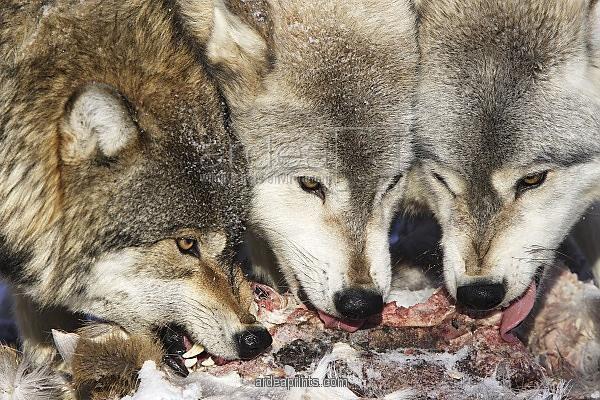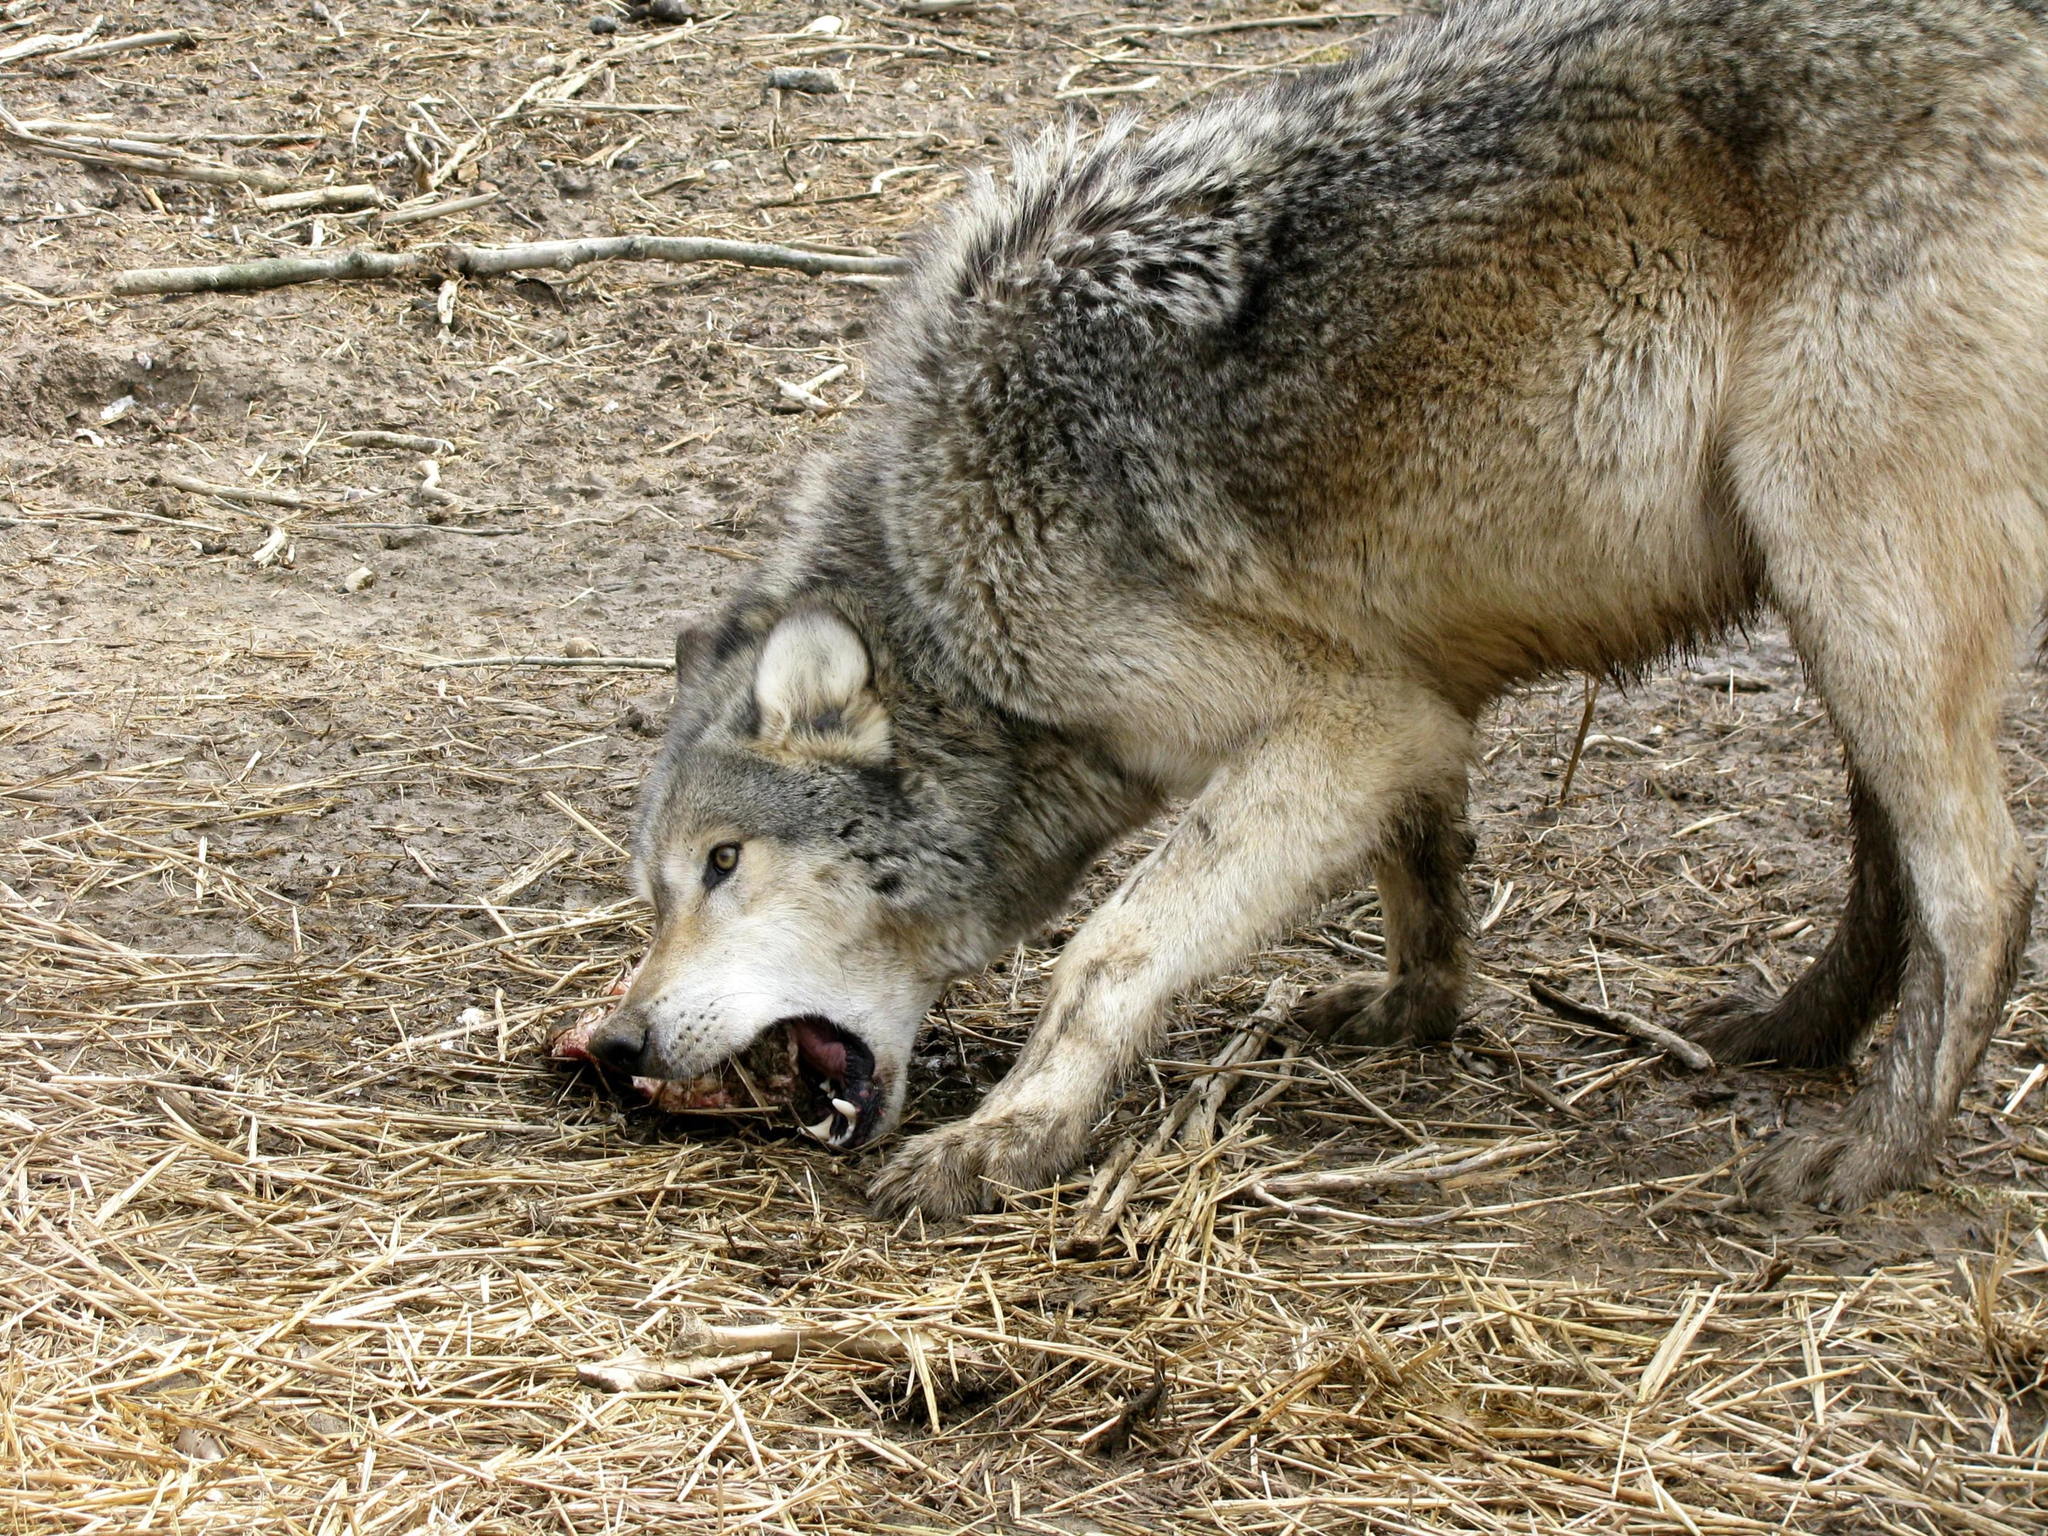The first image is the image on the left, the second image is the image on the right. Considering the images on both sides, is "In the image on the left, a wolf bares its teeth, while looking towards the camera person." valid? Answer yes or no. No. The first image is the image on the left, the second image is the image on the right. Assess this claim about the two images: "There is no more than one wolf in the right image.". Correct or not? Answer yes or no. Yes. 